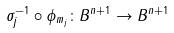<formula> <loc_0><loc_0><loc_500><loc_500>\sigma _ { j } ^ { - 1 } \circ \phi _ { m _ { j } } \colon B ^ { n + 1 } \rightarrow B ^ { n + 1 }</formula> 